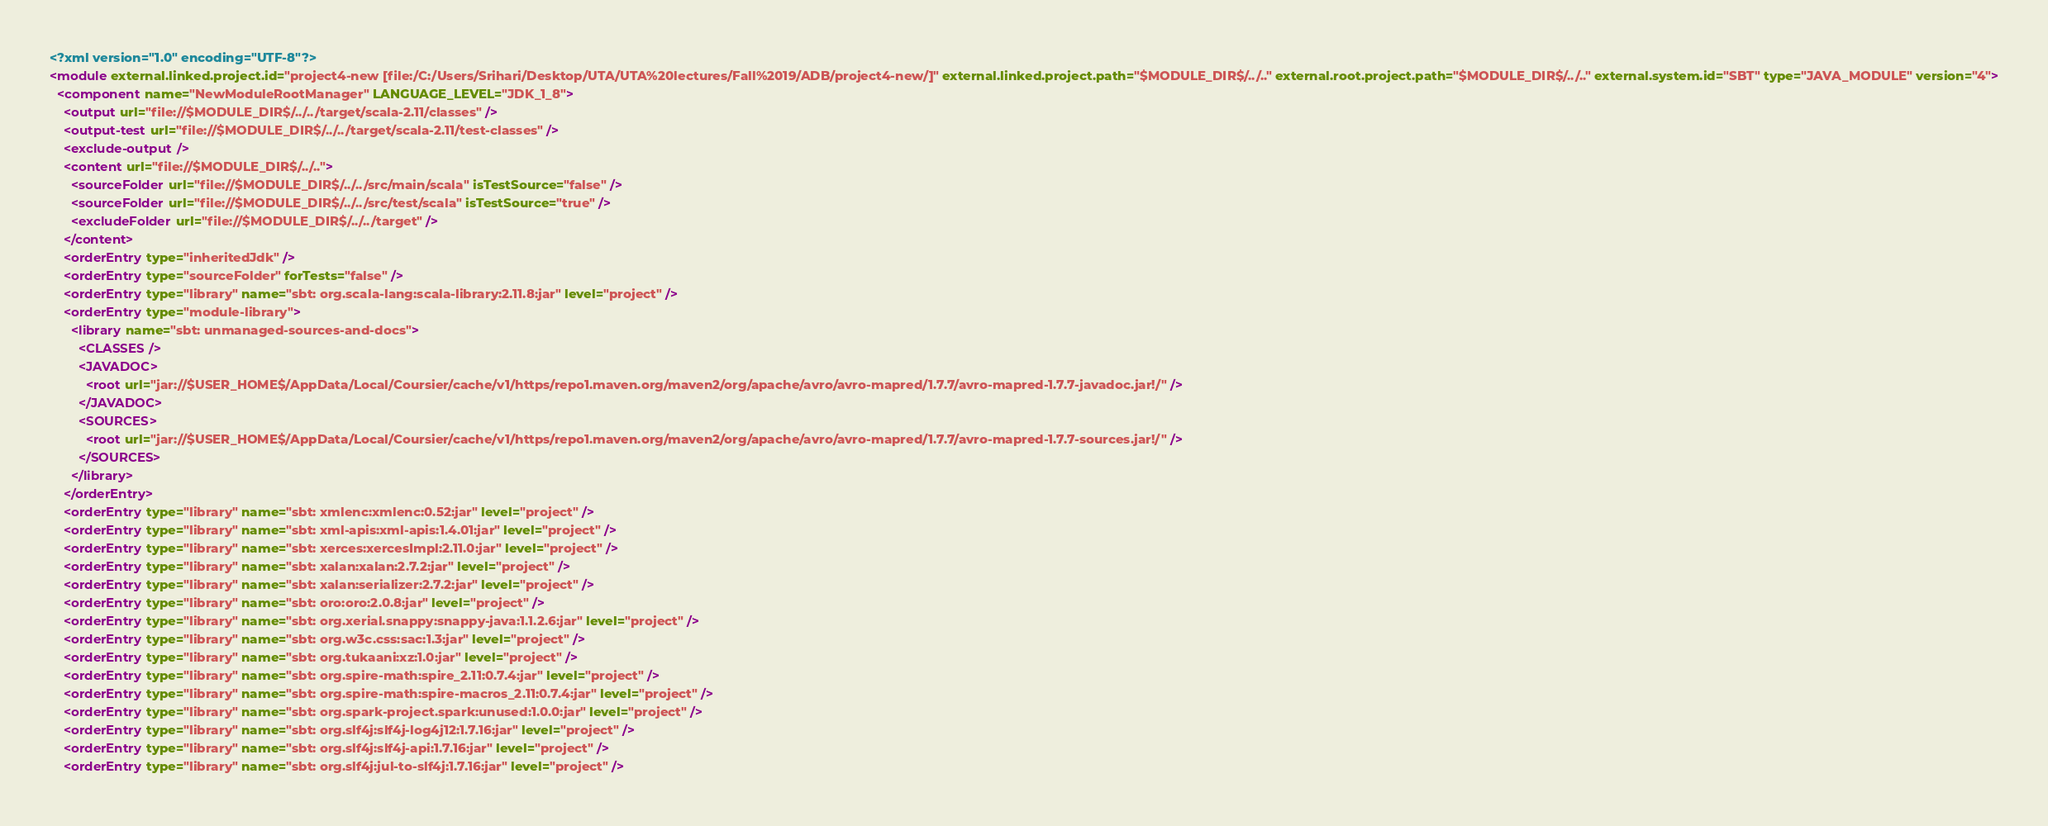Convert code to text. <code><loc_0><loc_0><loc_500><loc_500><_XML_><?xml version="1.0" encoding="UTF-8"?>
<module external.linked.project.id="project4-new [file:/C:/Users/Srihari/Desktop/UTA/UTA%20lectures/Fall%2019/ADB/project4-new/]" external.linked.project.path="$MODULE_DIR$/../.." external.root.project.path="$MODULE_DIR$/../.." external.system.id="SBT" type="JAVA_MODULE" version="4">
  <component name="NewModuleRootManager" LANGUAGE_LEVEL="JDK_1_8">
    <output url="file://$MODULE_DIR$/../../target/scala-2.11/classes" />
    <output-test url="file://$MODULE_DIR$/../../target/scala-2.11/test-classes" />
    <exclude-output />
    <content url="file://$MODULE_DIR$/../..">
      <sourceFolder url="file://$MODULE_DIR$/../../src/main/scala" isTestSource="false" />
      <sourceFolder url="file://$MODULE_DIR$/../../src/test/scala" isTestSource="true" />
      <excludeFolder url="file://$MODULE_DIR$/../../target" />
    </content>
    <orderEntry type="inheritedJdk" />
    <orderEntry type="sourceFolder" forTests="false" />
    <orderEntry type="library" name="sbt: org.scala-lang:scala-library:2.11.8:jar" level="project" />
    <orderEntry type="module-library">
      <library name="sbt: unmanaged-sources-and-docs">
        <CLASSES />
        <JAVADOC>
          <root url="jar://$USER_HOME$/AppData/Local/Coursier/cache/v1/https/repo1.maven.org/maven2/org/apache/avro/avro-mapred/1.7.7/avro-mapred-1.7.7-javadoc.jar!/" />
        </JAVADOC>
        <SOURCES>
          <root url="jar://$USER_HOME$/AppData/Local/Coursier/cache/v1/https/repo1.maven.org/maven2/org/apache/avro/avro-mapred/1.7.7/avro-mapred-1.7.7-sources.jar!/" />
        </SOURCES>
      </library>
    </orderEntry>
    <orderEntry type="library" name="sbt: xmlenc:xmlenc:0.52:jar" level="project" />
    <orderEntry type="library" name="sbt: xml-apis:xml-apis:1.4.01:jar" level="project" />
    <orderEntry type="library" name="sbt: xerces:xercesImpl:2.11.0:jar" level="project" />
    <orderEntry type="library" name="sbt: xalan:xalan:2.7.2:jar" level="project" />
    <orderEntry type="library" name="sbt: xalan:serializer:2.7.2:jar" level="project" />
    <orderEntry type="library" name="sbt: oro:oro:2.0.8:jar" level="project" />
    <orderEntry type="library" name="sbt: org.xerial.snappy:snappy-java:1.1.2.6:jar" level="project" />
    <orderEntry type="library" name="sbt: org.w3c.css:sac:1.3:jar" level="project" />
    <orderEntry type="library" name="sbt: org.tukaani:xz:1.0:jar" level="project" />
    <orderEntry type="library" name="sbt: org.spire-math:spire_2.11:0.7.4:jar" level="project" />
    <orderEntry type="library" name="sbt: org.spire-math:spire-macros_2.11:0.7.4:jar" level="project" />
    <orderEntry type="library" name="sbt: org.spark-project.spark:unused:1.0.0:jar" level="project" />
    <orderEntry type="library" name="sbt: org.slf4j:slf4j-log4j12:1.7.16:jar" level="project" />
    <orderEntry type="library" name="sbt: org.slf4j:slf4j-api:1.7.16:jar" level="project" />
    <orderEntry type="library" name="sbt: org.slf4j:jul-to-slf4j:1.7.16:jar" level="project" /></code> 